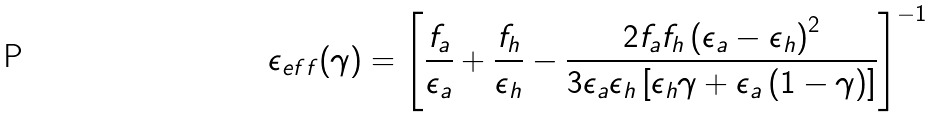Convert formula to latex. <formula><loc_0><loc_0><loc_500><loc_500>\epsilon _ { e f f } ( \gamma ) = \left [ \frac { f _ { a } } { \epsilon _ { a } } + \frac { f _ { h } } { \epsilon _ { h } } - \frac { 2 f _ { a } f _ { h } \left ( \epsilon _ { a } - \epsilon _ { h } \right ) ^ { 2 } } { 3 \epsilon _ { a } \epsilon _ { h } \left [ \epsilon _ { h } \gamma + \epsilon _ { a } \left ( 1 - \gamma \right ) \right ] } \right ] ^ { - 1 }</formula> 